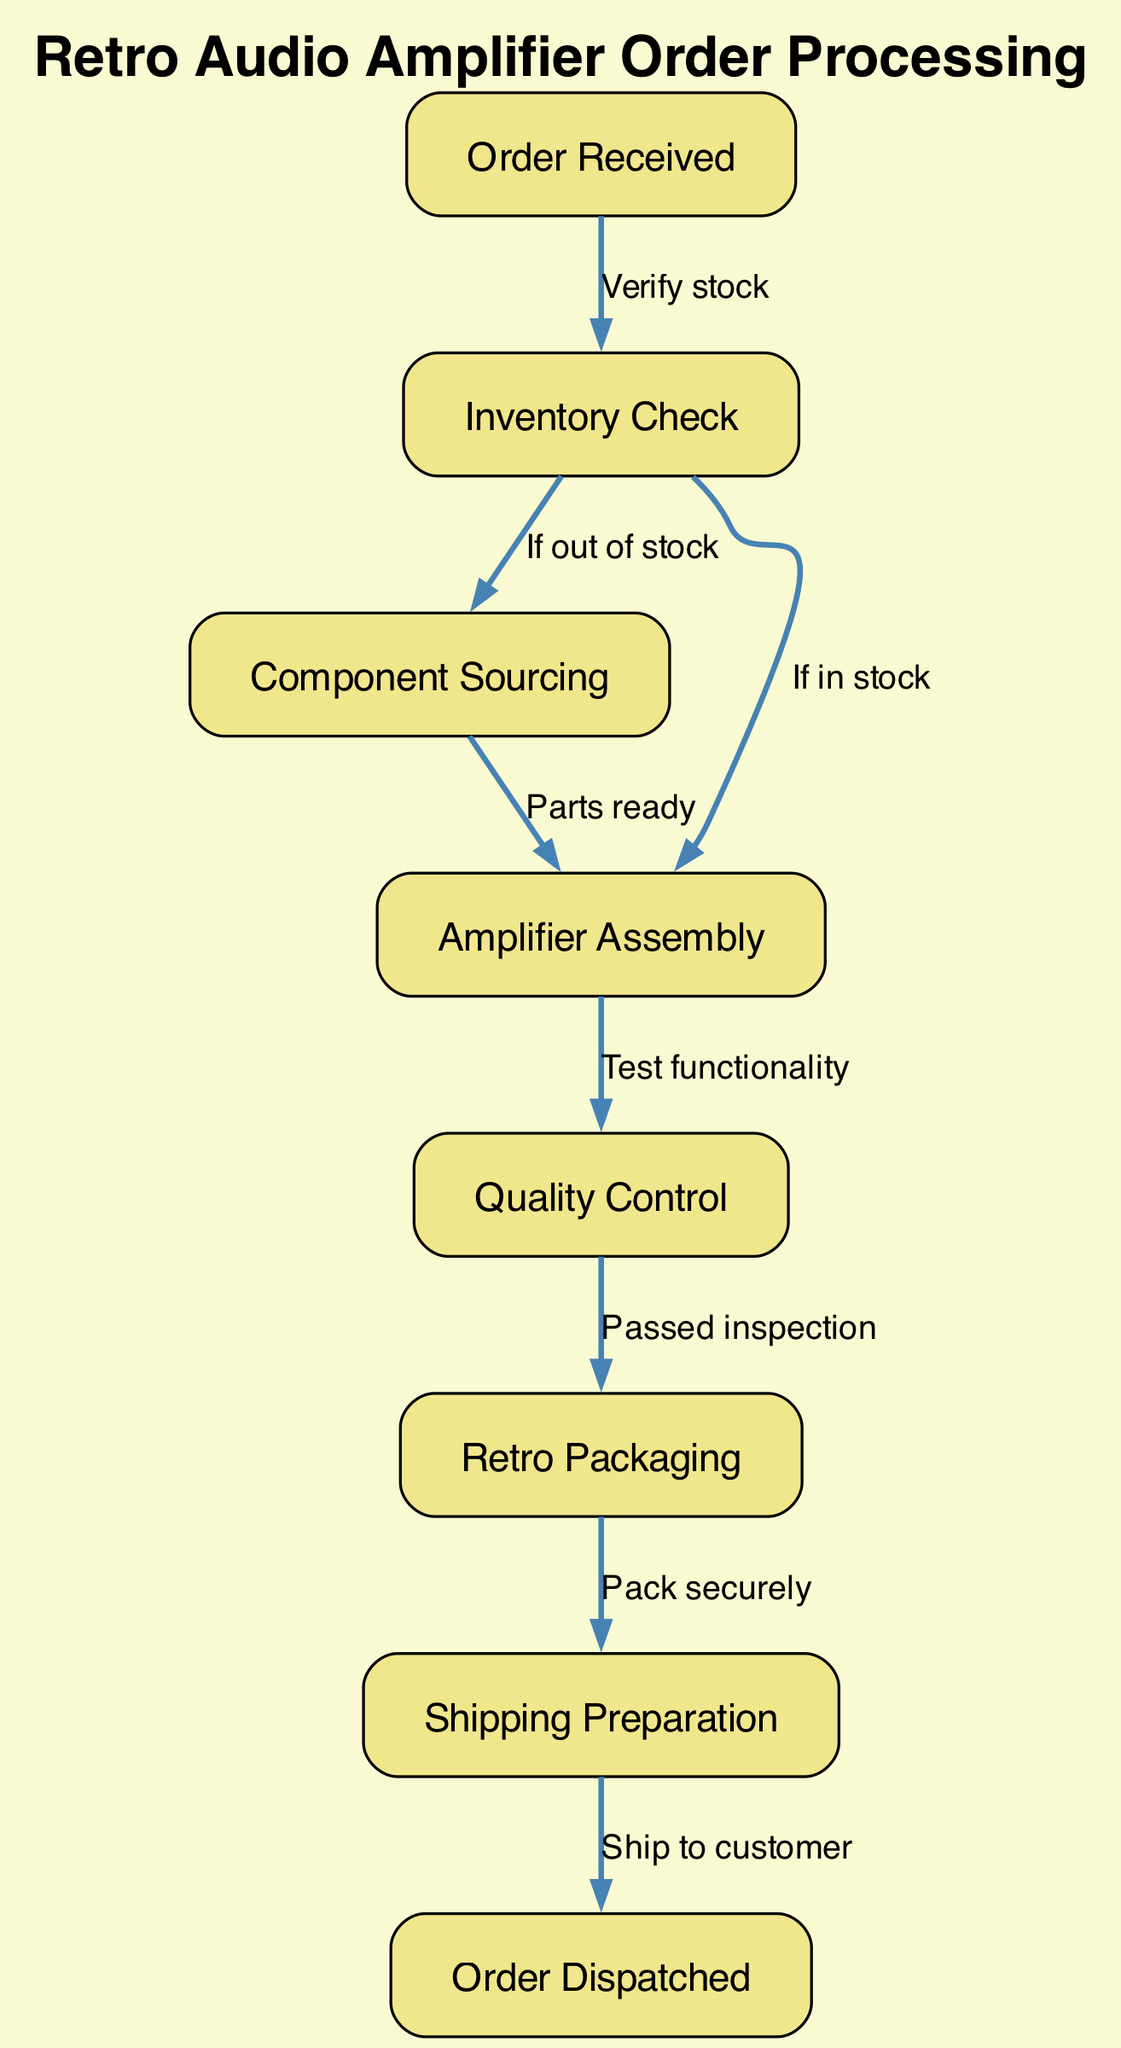What is the first stage in the order processing? The first stage is represented by the node labeled "Order Received." This node initiates the process where a customer's order is acknowledged.
Answer: Order Received How many total stages are there in the order processing? To find the total number of stages (or nodes), we can count the distinct stages: Order Received, Inventory Check, Component Sourcing, Amplifier Assembly, Quality Control, Retro Packaging, Shipping Preparation, and Order Dispatched, which totals 8 stages.
Answer: 8 What is the next step after "Quality Control"? After passing "Quality Control," the next step indicated by the directed edge is "Retro Packaging." Thus, once the inspection is passed, the product moves to packaging.
Answer: Retro Packaging What happens if the inventory check reveals items are in stock? If the inventory check finds items in stock, the process directly moves to the "Amplifier Assembly" stage as indicated by the edge labeled "If in stock."
Answer: Amplifier Assembly Which stage precedes "Order Dispatched"? The stage that precedes "Order Dispatched" is "Shipping Preparation." The directed edge shows that shipping preparation occurs before dispatching the order.
Answer: Shipping Preparation What triggers the transition from "Component Sourcing" to "Amplifier Assembly"? The transition occurs when the parts are ready, as indicated by the edge labeled "Parts ready." This shows that component sourcing concludes with the readiness of the parts for assembly.
Answer: Parts ready What stage occurs after "Retro Packaging"? The stage that occurs after "Retro Packaging" is "Shipping Preparation." The diagram illustrates a direct transition from packaging to preparing for shipping.
Answer: Shipping Preparation What indicates a successful outcome in "Quality Control"? A successful outcome in "Quality Control" is indicated by the label "Passed inspection," which shows that the product moves forward to the next stage only if it passes inspection.
Answer: Passed inspection 